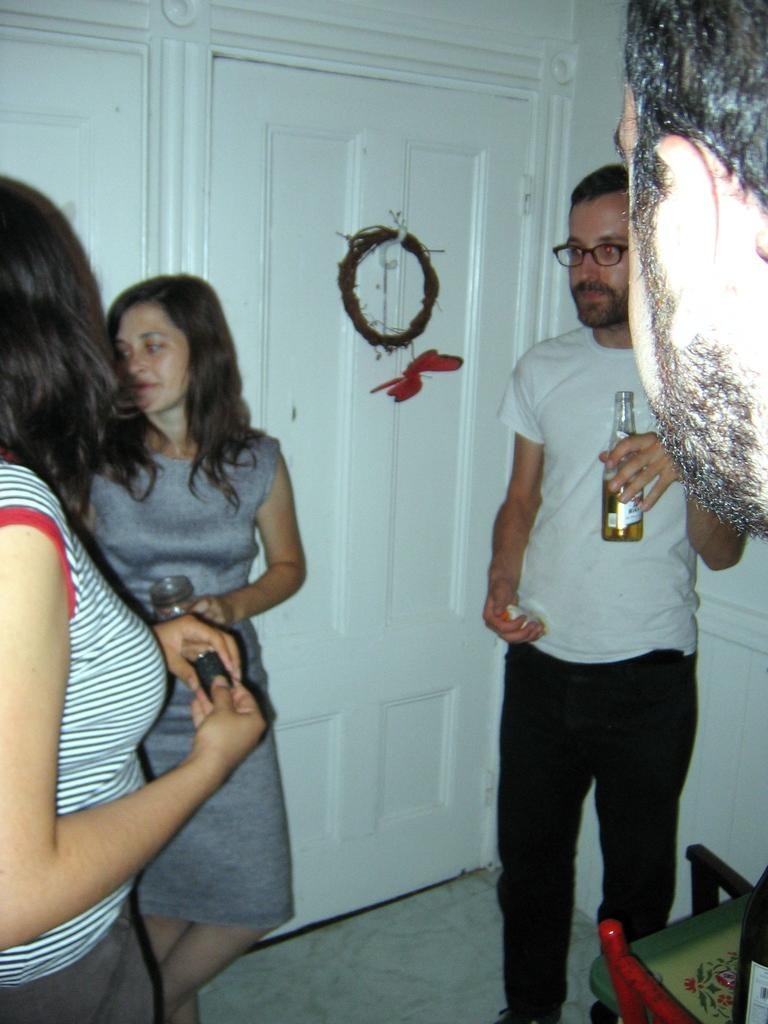How many people are in the image? There are three people in the image: two girls and a man. What are the girls carrying in the image? The girls are carrying bottles in the image. What is the man carrying in the image? The man is carrying a bottle in the image. What can be seen in the background of the image? There is a door in the background of the image. What type of furniture is present in the image? There is a chair in the image. Can you see a pest crawling on the chair in the image? There is no pest crawling on the chair in the image. Is there a tiger visible in the image? There is no tiger present in the image. 